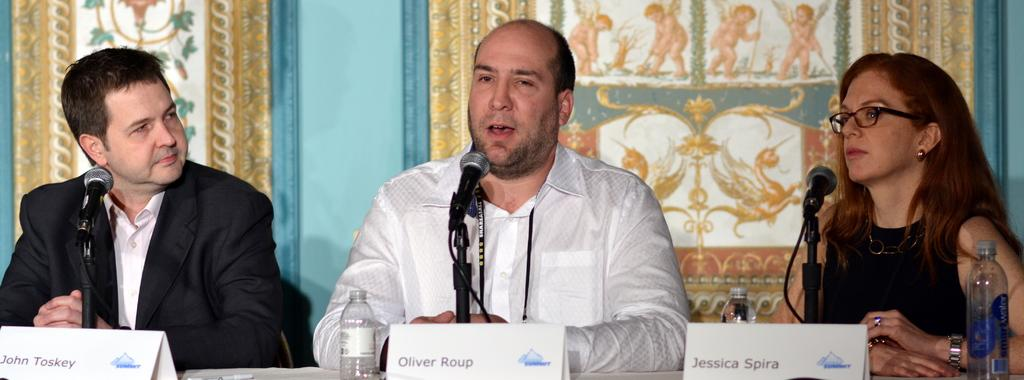How many people are sitting in the image? There are three persons sitting in the image. What can be seen on the wall behind the persons? There is a wall in the background of the image. What items are present on the table in the image? There are objects on a table in the image. What objects are used for amplifying sound in the image? There are microphones in the image. What items are visible in the image that might contain liquid? There are bottles in the image. What type of egg is being used to sweeten the conversation in the image? There is no egg present in the image, and therefore no such activity can be observed. 